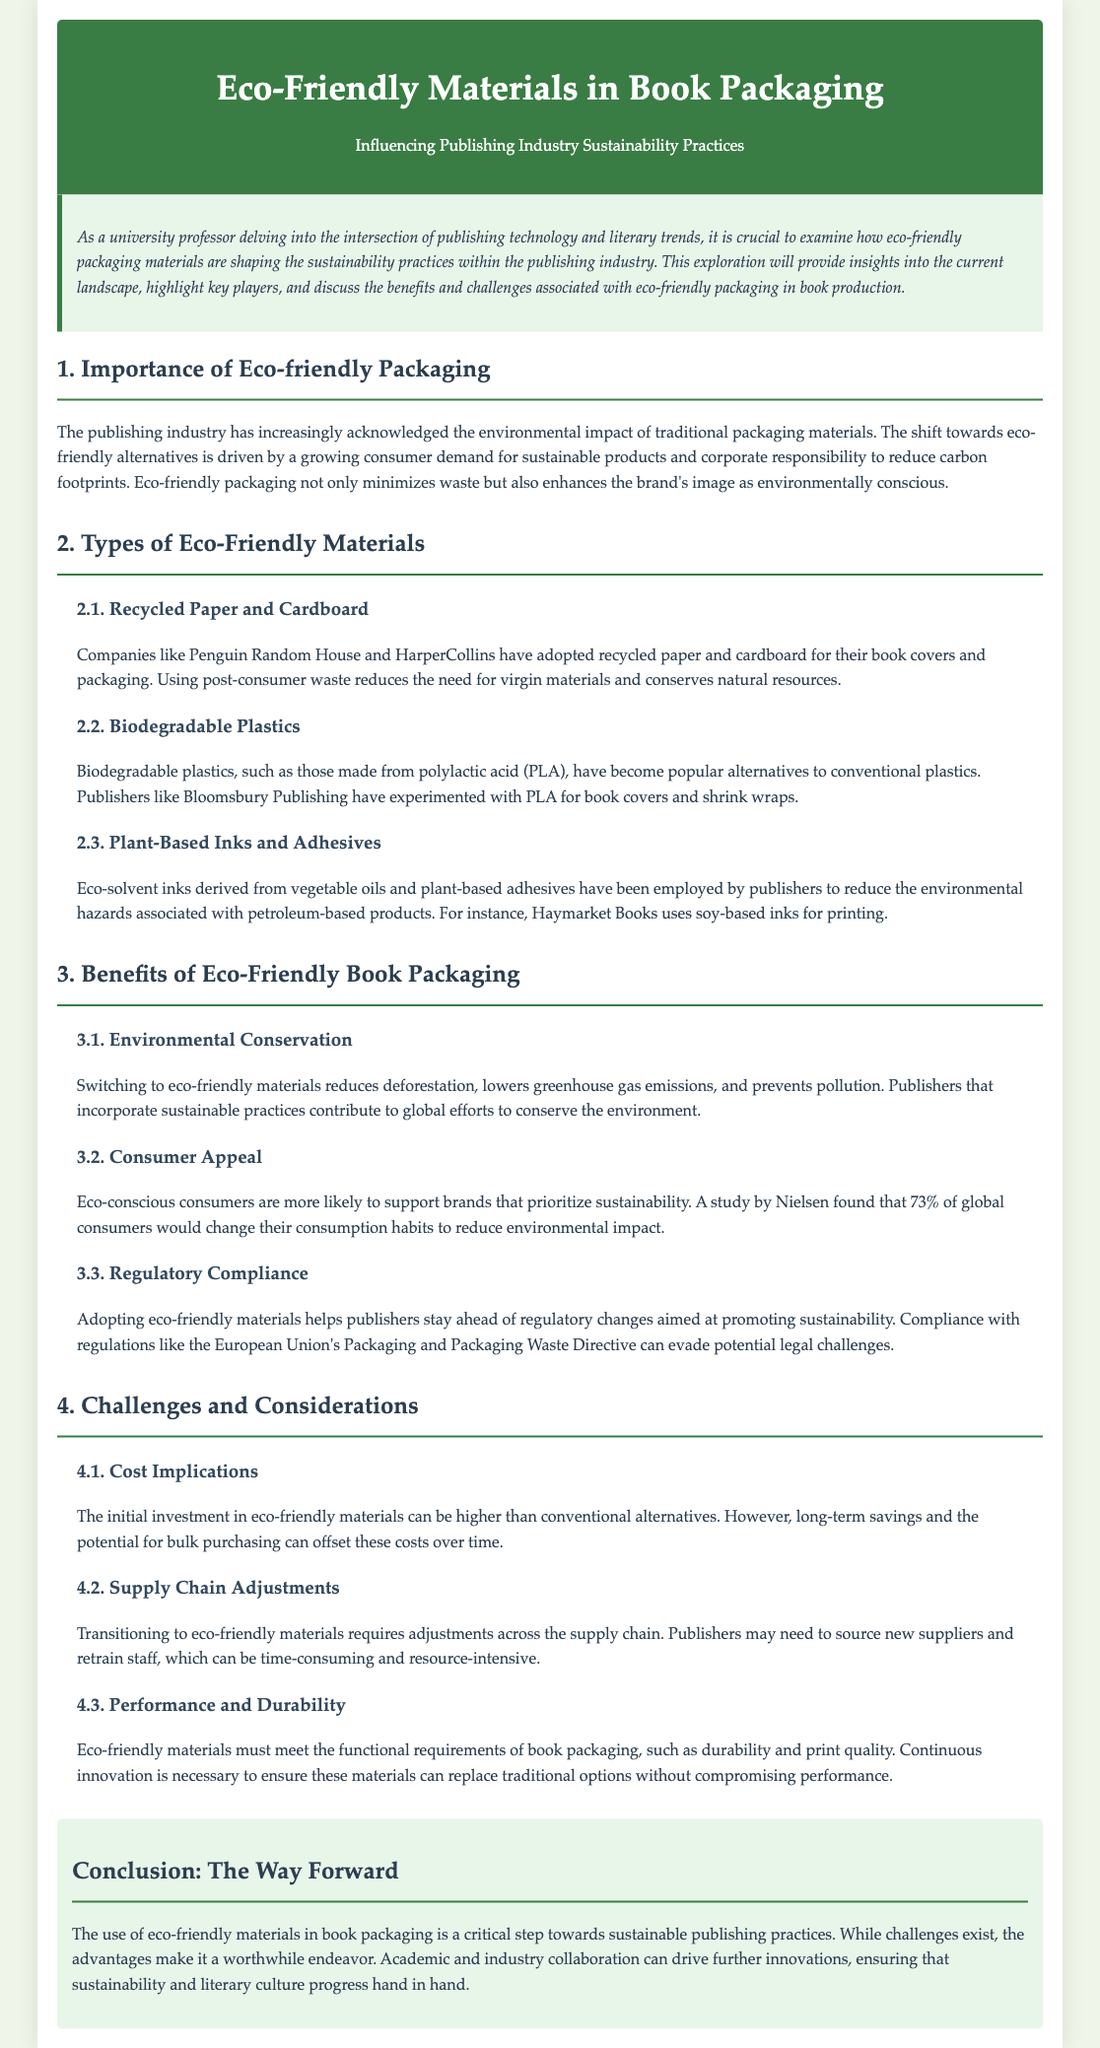What is eco-friendly packaging? Eco-friendly packaging refers to materials that minimize environmental impact and promote sustainability in the publishing industry.
Answer: Eco-friendly packaging Who are two companies using recycled paper for book covers? The document mentions Penguin Random House and HarperCollins as companies that have adopted recycled paper and cardboard.
Answer: Penguin Random House and HarperCollins What is one type of biodegradable plastic mentioned? The document highlights polylactic acid (PLA) as a popular alternative to conventional plastics in book packaging.
Answer: PLA What percentage of global consumers would change consumption habits for sustainability? A study by Nielsen indicates that 73% of global consumers are willing to change their habits to be more sustainable.
Answer: 73% What is one challenge associated with eco-friendly packaging? The document identifies cost implications as a significant challenge for publishers transitioning to eco-friendly materials.
Answer: Cost implications What is a benefit of eco-friendly packaging in terms of regulation? Adoption of eco-friendly materials helps publishers comply with regulations like the European Union's Packaging Directive.
Answer: Regulatory compliance What is a consideration regarding the performance of eco-friendly materials? The document mentions that eco-friendly materials must maintain durability and print quality in book packaging.
Answer: Durability and print quality What do the authors suggest as a way forward for sustainable publishing? The conclusion states that academic and industry collaboration can drive innovations in sustainable practices.
Answer: Collaboration 